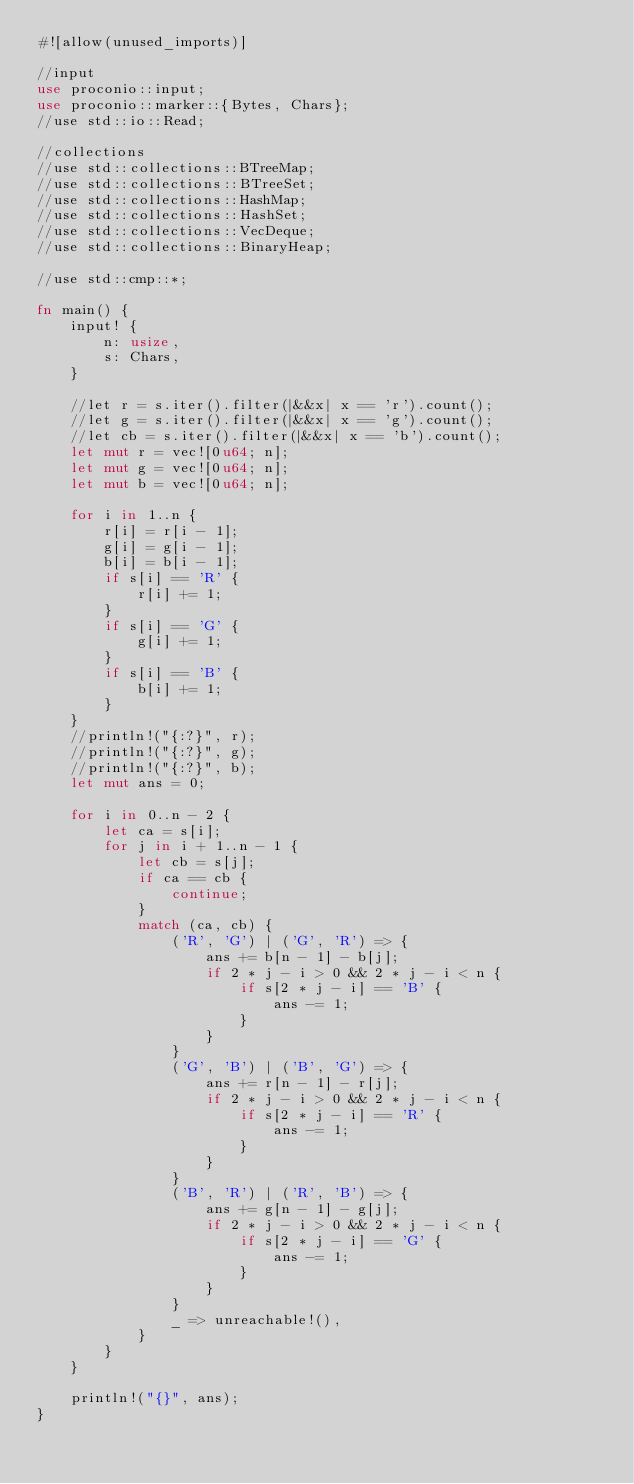Convert code to text. <code><loc_0><loc_0><loc_500><loc_500><_Rust_>#![allow(unused_imports)]
 
//input
use proconio::input;
use proconio::marker::{Bytes, Chars};
//use std::io::Read;
 
//collections
//use std::collections::BTreeMap;
//use std::collections::BTreeSet;
//use std::collections::HashMap;
//use std::collections::HashSet;
//use std::collections::VecDeque;
//use std::collections::BinaryHeap;
 
//use std::cmp::*;
 
fn main() {
    input! {
        n: usize,
        s: Chars,
    }
 
    //let r = s.iter().filter(|&&x| x == 'r').count();
    //let g = s.iter().filter(|&&x| x == 'g').count();
    //let cb = s.iter().filter(|&&x| x == 'b').count();
    let mut r = vec![0u64; n];
    let mut g = vec![0u64; n];
    let mut b = vec![0u64; n];
 
    for i in 1..n {
        r[i] = r[i - 1];
        g[i] = g[i - 1];
        b[i] = b[i - 1];
        if s[i] == 'R' {
            r[i] += 1;
        }
        if s[i] == 'G' {
            g[i] += 1;
        }
        if s[i] == 'B' {
            b[i] += 1;
        }
    }
    //println!("{:?}", r);
    //println!("{:?}", g);
    //println!("{:?}", b);
    let mut ans = 0;
 
    for i in 0..n - 2 {
        let ca = s[i];
        for j in i + 1..n - 1 {
            let cb = s[j];
            if ca == cb {
                continue;
            }
            match (ca, cb) {
                ('R', 'G') | ('G', 'R') => {
                    ans += b[n - 1] - b[j];
                    if 2 * j - i > 0 && 2 * j - i < n {
                        if s[2 * j - i] == 'B' {
                            ans -= 1;
                        }
                    }
                }
                ('G', 'B') | ('B', 'G') => {
                    ans += r[n - 1] - r[j];
                    if 2 * j - i > 0 && 2 * j - i < n {
                        if s[2 * j - i] == 'R' {
                            ans -= 1;
                        }
                    }
                }
                ('B', 'R') | ('R', 'B') => {
                    ans += g[n - 1] - g[j];
                    if 2 * j - i > 0 && 2 * j - i < n {
                        if s[2 * j - i] == 'G' {
                            ans -= 1;
                        }
                    }
                }
                _ => unreachable!(),
            }
        }
    }
 
    println!("{}", ans);
}</code> 